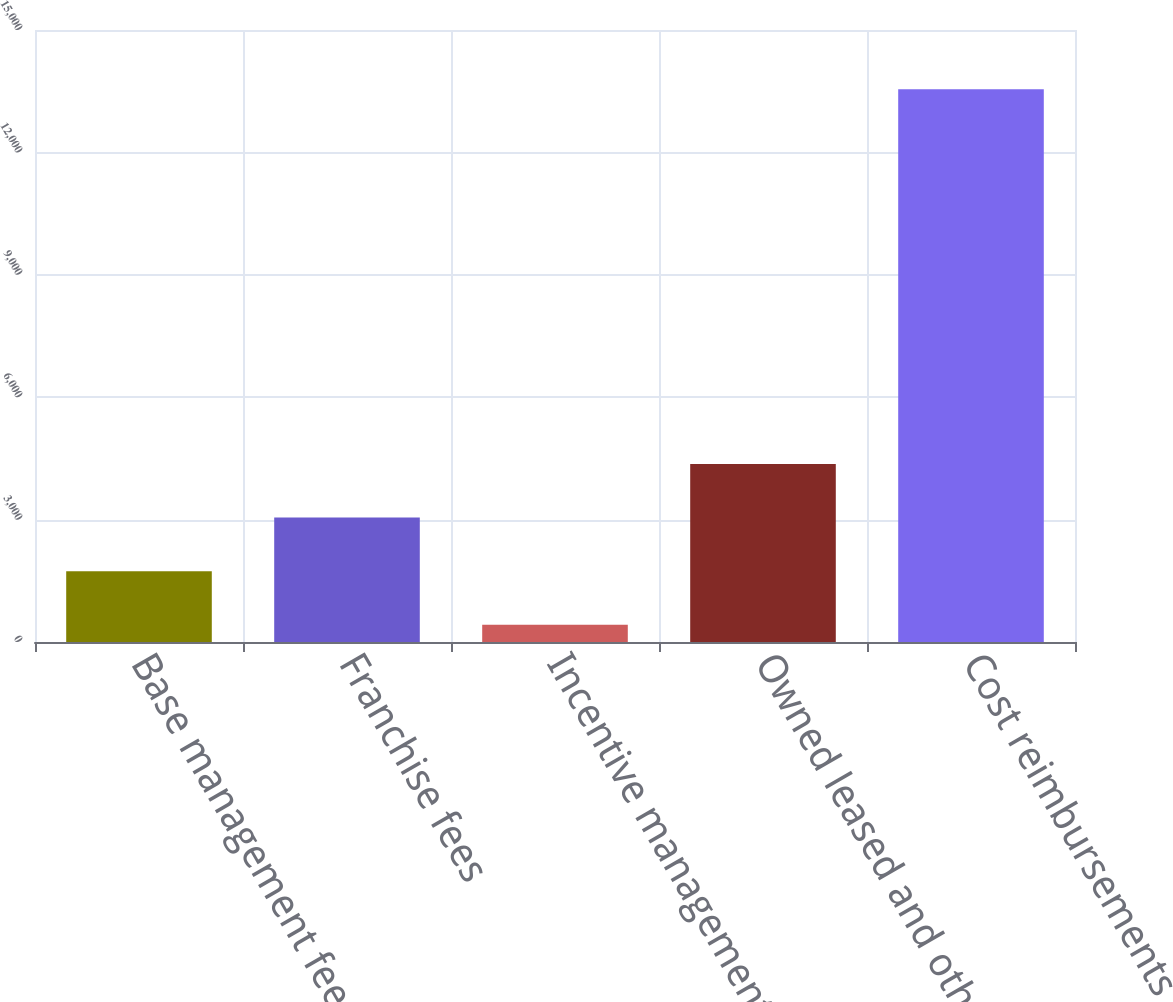Convert chart to OTSL. <chart><loc_0><loc_0><loc_500><loc_500><bar_chart><fcel>Base management fees<fcel>Franchise fees<fcel>Incentive management fees<fcel>Owned leased and other revenue<fcel>Cost reimbursements<nl><fcel>1737.1<fcel>3049.2<fcel>425<fcel>4361.3<fcel>13546<nl></chart> 